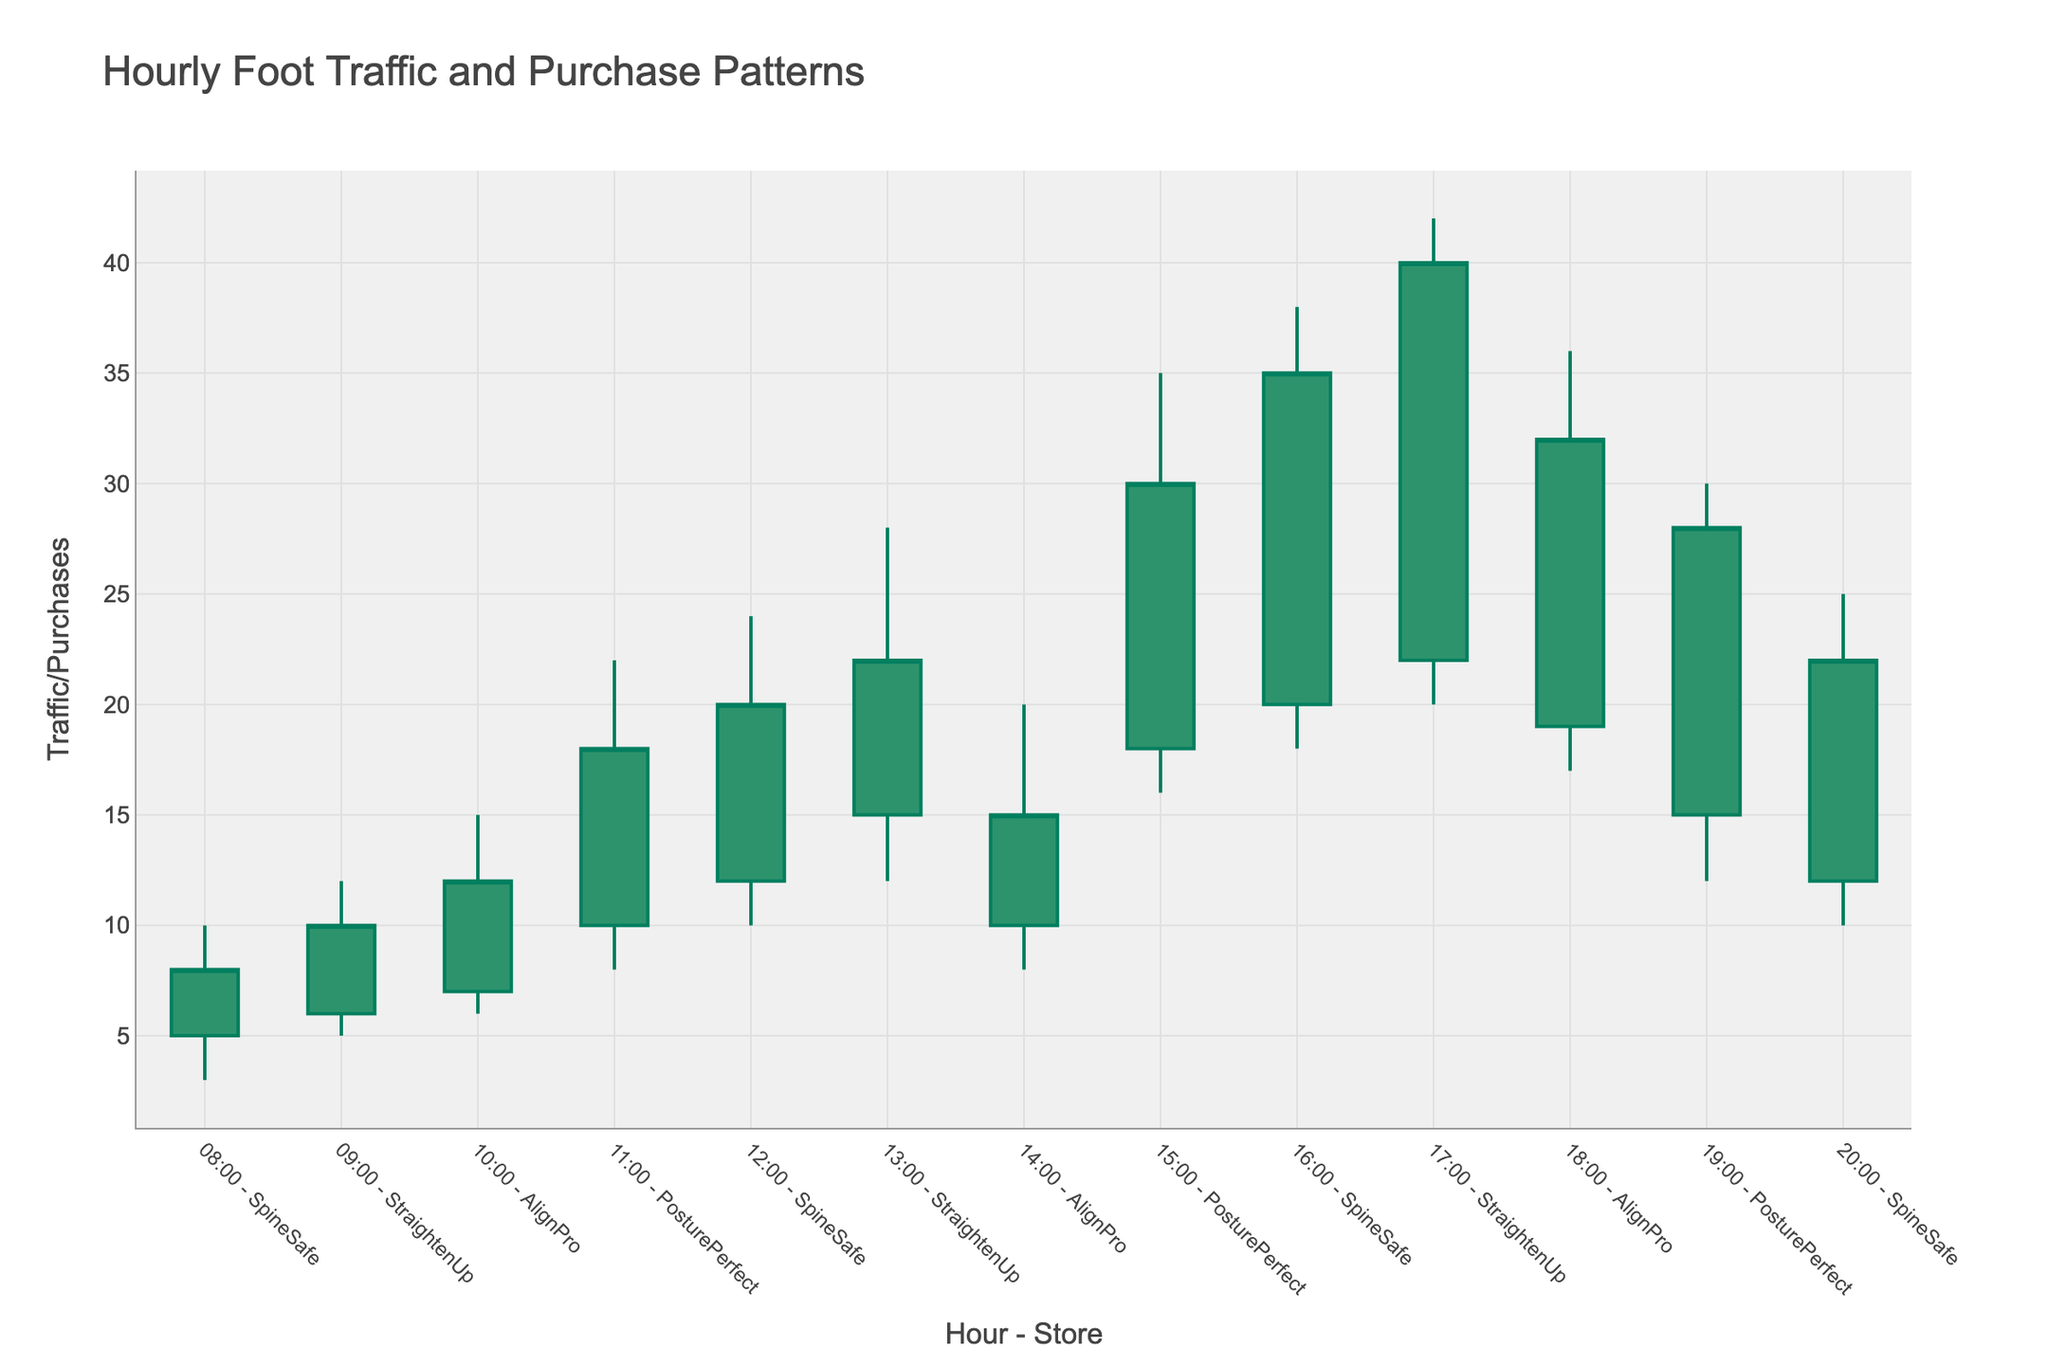What's the title of the figure? The title of a plot is displayed at the top of the figure, giving a summary of what it represents. Here, the title "Hourly Foot Traffic and Purchase Patterns" is at the top, indicating the subject of the candlestick plot.
Answer: Hourly Foot Traffic and Purchase Patterns What is the overall trend in foot traffic and purchase patterns across all stores? By looking at the candlestick bars for each hour and store, notice that the height and width of the plots increase over time, indicating an overall increase in foot traffic and purchase patterns as it gets later in the day.
Answer: Increasing trend Which store had the highest traffic or purchase activity peak, and at what time? The "High" values in candlestick plots represent the peak traffic or purchase activity for each hour and store. The highest peak can be seen in the 17:00 - StraightenUp candlestick, which reaches a "High" value of 42.
Answer: StraightenUp at 17:00 Did any store experience a decline in foot traffic/purchase from open to close during any hour? By observing the color and direction of the candlesticks: decreasing candlesticks are colored differently (decreasing fillcolor), we see that from 14:00 - 15:00, AlignPro, and from 19:00 - 20:00, PosturePerfect experience a drop since their Close values are less than their Open values.
Answer: AlignPro at 14:00, and PosturePerfect at 19:00 What's the difference between the maximum and minimum foot traffic/purchase value during the 12:00 - 13:00 hour for SpineSafe? To find the difference between the maximum and minimum values, we subtract the lowest value (Low) from the highest value (High). For SpineSafe at 12:00 - 13:00, the High is 24, and the Low is 10, thus 24 - 10 = 14.
Answer: 14 How many stores had their closing values the same as their opening values at any hour? We determine this by checking the candlestick bars where the Open values equal the Close values. Here, none of the candlesticks have the same Open and Close values, indicating no store experienced identical foot traffic/purchases from Open to Close at any hour.
Answer: 0 stores Which store at 15:00 had the widest range of foot traffic/purchase values from high to low? The range can be calculated by the difference between High and Low values. At 15:00 hour, PosturePerfect (High 35, Low 16) has a range of 19, while other stores have lower ranges.
Answer: PosturePerfect When did SpineSafe have its highest closing value, and what was the value? By observing the closing values for SpineSafe across all hours, its highest closing value is at 16:00 with a Close of 35.
Answer: 16:00, 35 